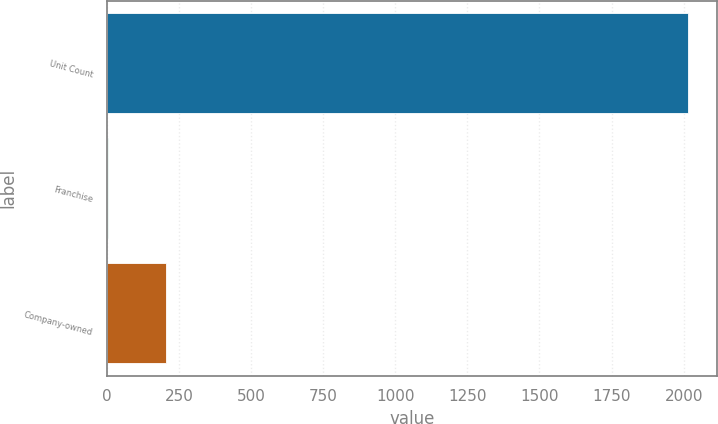<chart> <loc_0><loc_0><loc_500><loc_500><bar_chart><fcel>Unit Count<fcel>Franchise<fcel>Company-owned<nl><fcel>2016<fcel>4<fcel>205.2<nl></chart> 